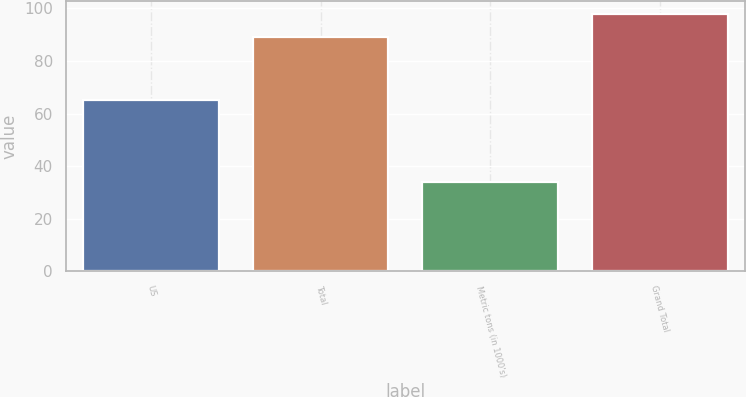Convert chart. <chart><loc_0><loc_0><loc_500><loc_500><bar_chart><fcel>US<fcel>Total<fcel>Metric tons (in 1000's)<fcel>Grand Total<nl><fcel>65<fcel>89<fcel>34<fcel>98<nl></chart> 